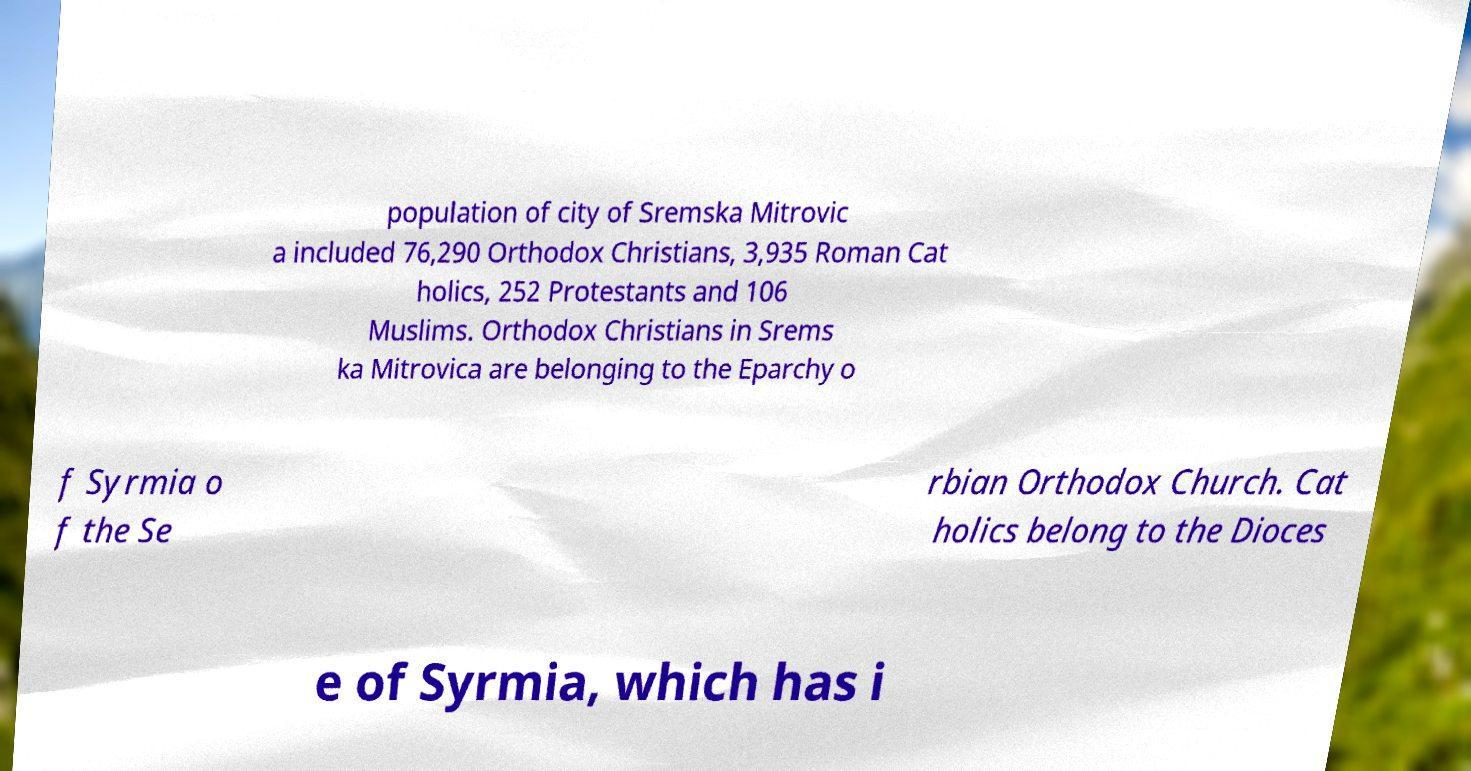Could you assist in decoding the text presented in this image and type it out clearly? population of city of Sremska Mitrovic a included 76,290 Orthodox Christians, 3,935 Roman Cat holics, 252 Protestants and 106 Muslims. Orthodox Christians in Srems ka Mitrovica are belonging to the Eparchy o f Syrmia o f the Se rbian Orthodox Church. Cat holics belong to the Dioces e of Syrmia, which has i 